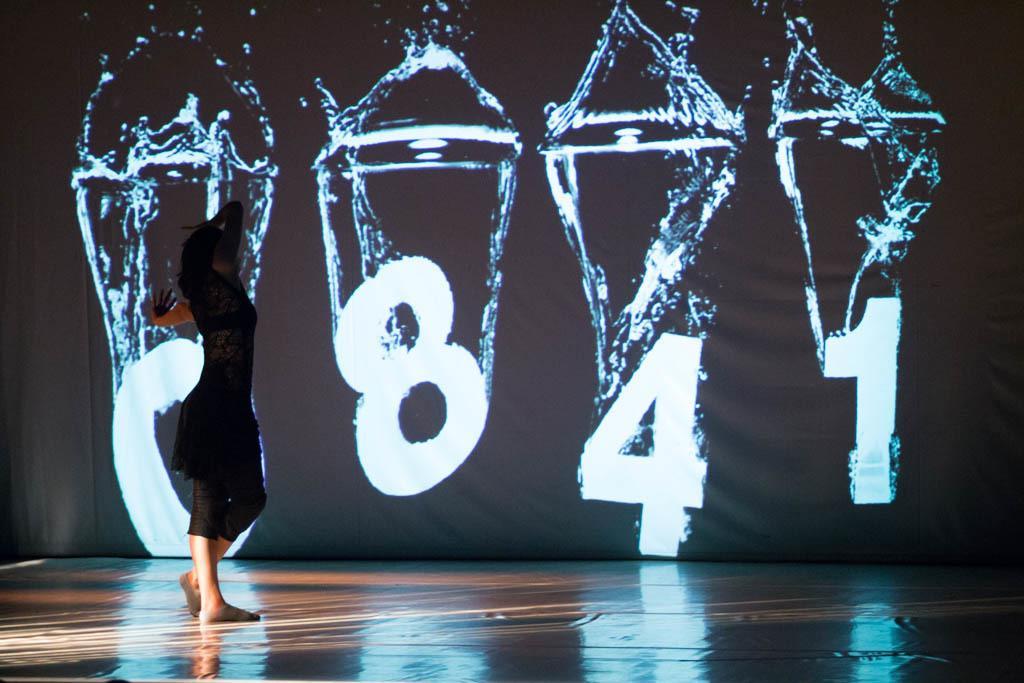In one or two sentences, can you explain what this image depicts? In this image I can see the stage and on the stage I can see a person wearing black color dress is stunning. In the background I can see a huge screen. 